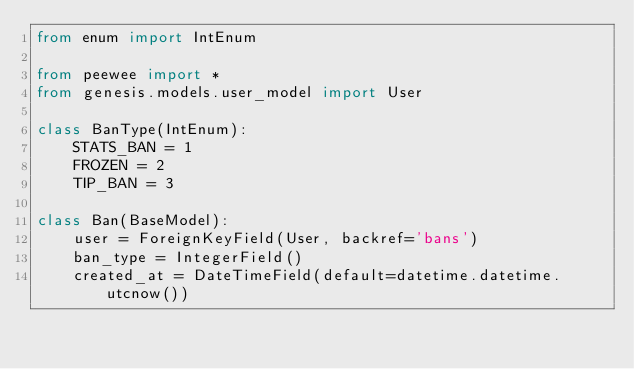<code> <loc_0><loc_0><loc_500><loc_500><_Python_>from enum import IntEnum

from peewee import *
from genesis.models.user_model import User

class BanType(IntEnum):
    STATS_BAN = 1
    FROZEN = 2
    TIP_BAN = 3

class Ban(BaseModel):
    user = ForeignKeyField(User, backref='bans')
    ban_type = IntegerField()
    created_at = DateTimeField(default=datetime.datetime.utcnow())

</code> 